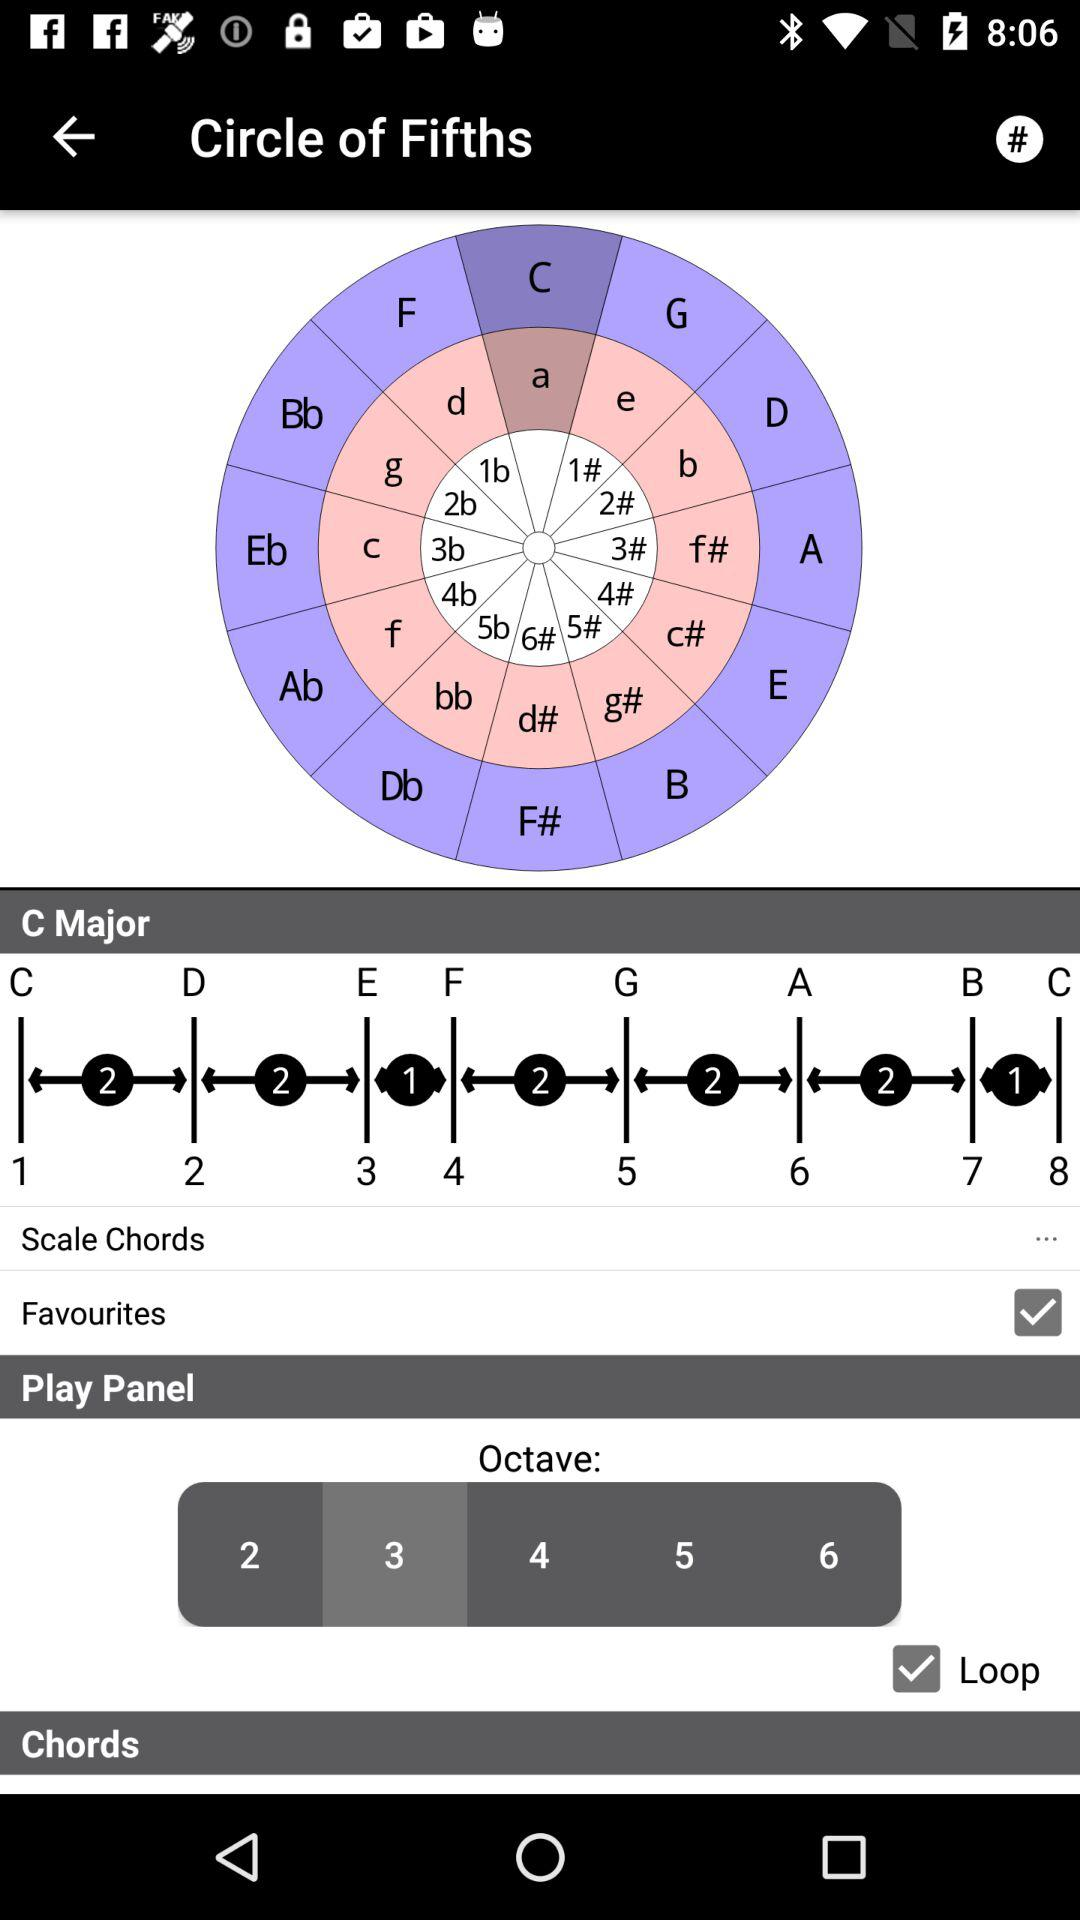What option has been chosen in octave? The option that has been chosen in octave is 3. 